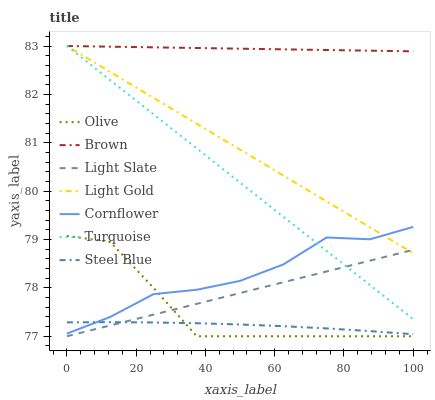Does Steel Blue have the minimum area under the curve?
Answer yes or no. Yes. Does Brown have the maximum area under the curve?
Answer yes or no. Yes. Does Turquoise have the minimum area under the curve?
Answer yes or no. No. Does Turquoise have the maximum area under the curve?
Answer yes or no. No. Is Light Slate the smoothest?
Answer yes or no. Yes. Is Olive the roughest?
Answer yes or no. Yes. Is Turquoise the smoothest?
Answer yes or no. No. Is Turquoise the roughest?
Answer yes or no. No. Does Light Slate have the lowest value?
Answer yes or no. Yes. Does Turquoise have the lowest value?
Answer yes or no. No. Does Light Gold have the highest value?
Answer yes or no. Yes. Does Cornflower have the highest value?
Answer yes or no. No. Is Olive less than Brown?
Answer yes or no. Yes. Is Cornflower greater than Light Slate?
Answer yes or no. Yes. Does Cornflower intersect Turquoise?
Answer yes or no. Yes. Is Cornflower less than Turquoise?
Answer yes or no. No. Is Cornflower greater than Turquoise?
Answer yes or no. No. Does Olive intersect Brown?
Answer yes or no. No. 